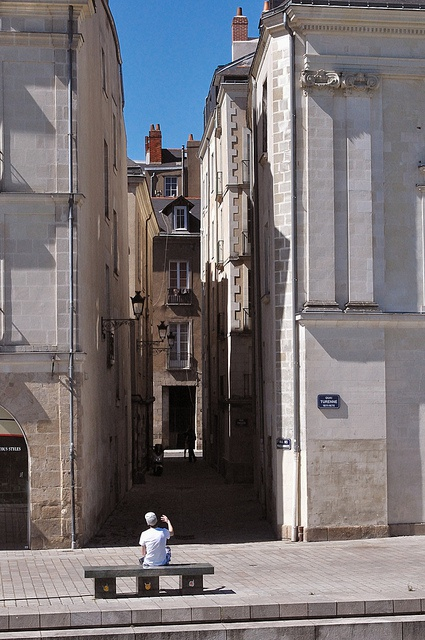Describe the objects in this image and their specific colors. I can see bench in gray, black, and darkgray tones, people in gray, white, and darkgray tones, and people in gray, black, and darkgray tones in this image. 